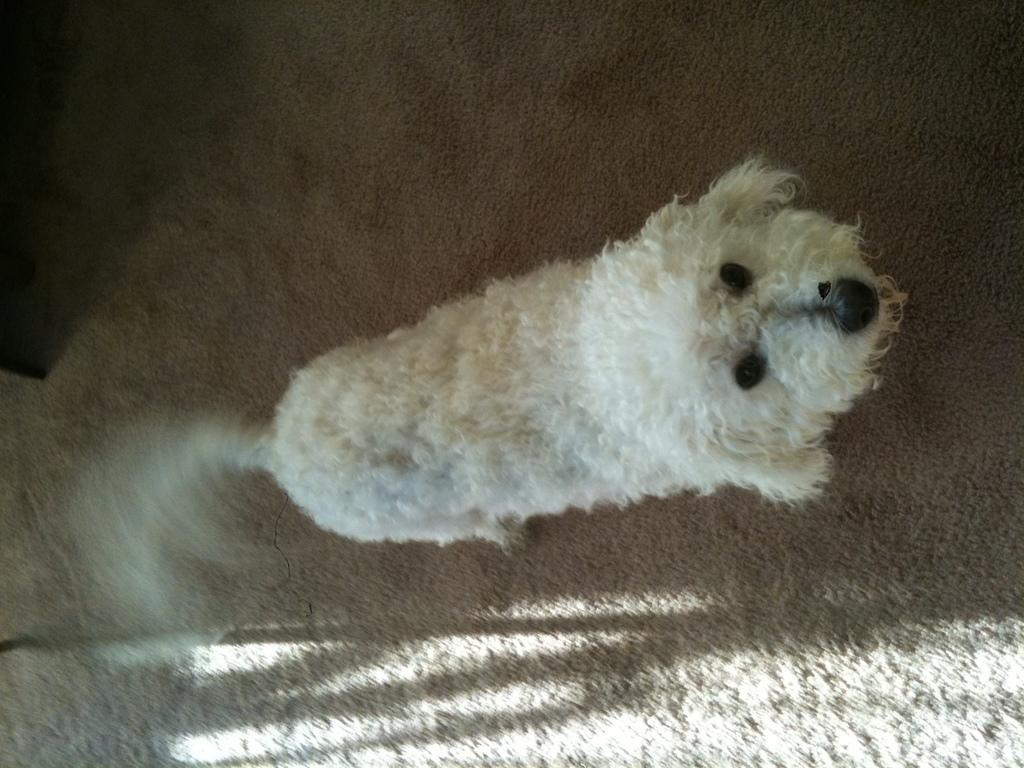How would you summarize this image in a sentence or two? In the image there is a dog standing on the mat. 